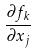Convert formula to latex. <formula><loc_0><loc_0><loc_500><loc_500>\frac { \partial f _ { k } } { \partial x _ { j } }</formula> 